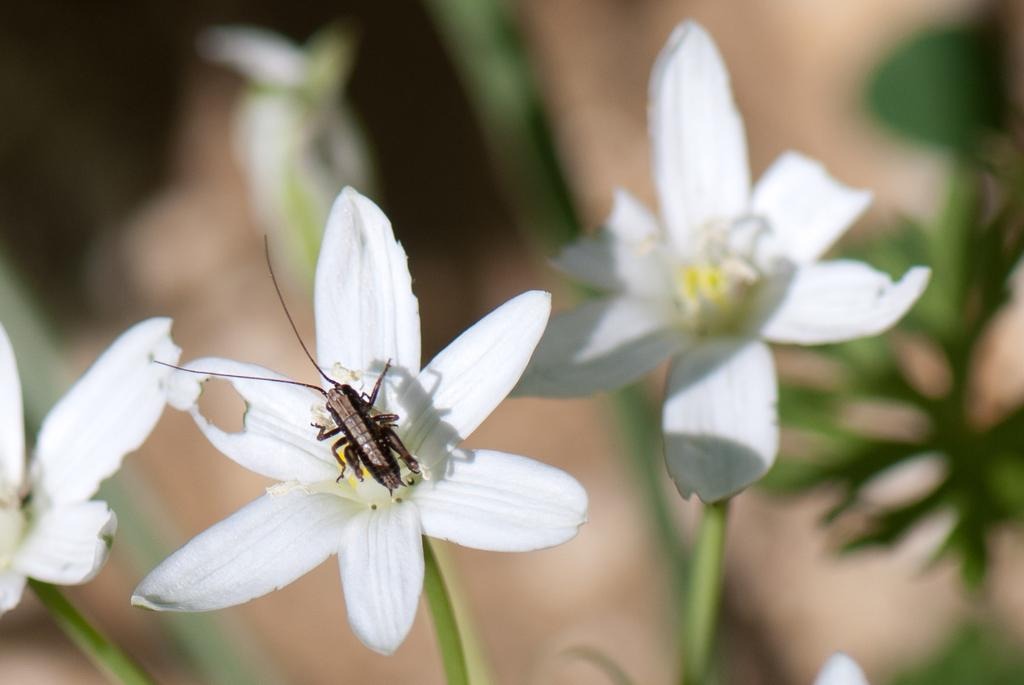What is the main subject in the middle of the image? There is an insect in the middle of the image. Where is the insect located? The insect is on a flower. What else can be seen in the image besides the insect? There are plants visible in the image. What type of basin can be seen in the image? There is no basin present in the image. How many islands are visible in the image? There are no islands visible in the image. 